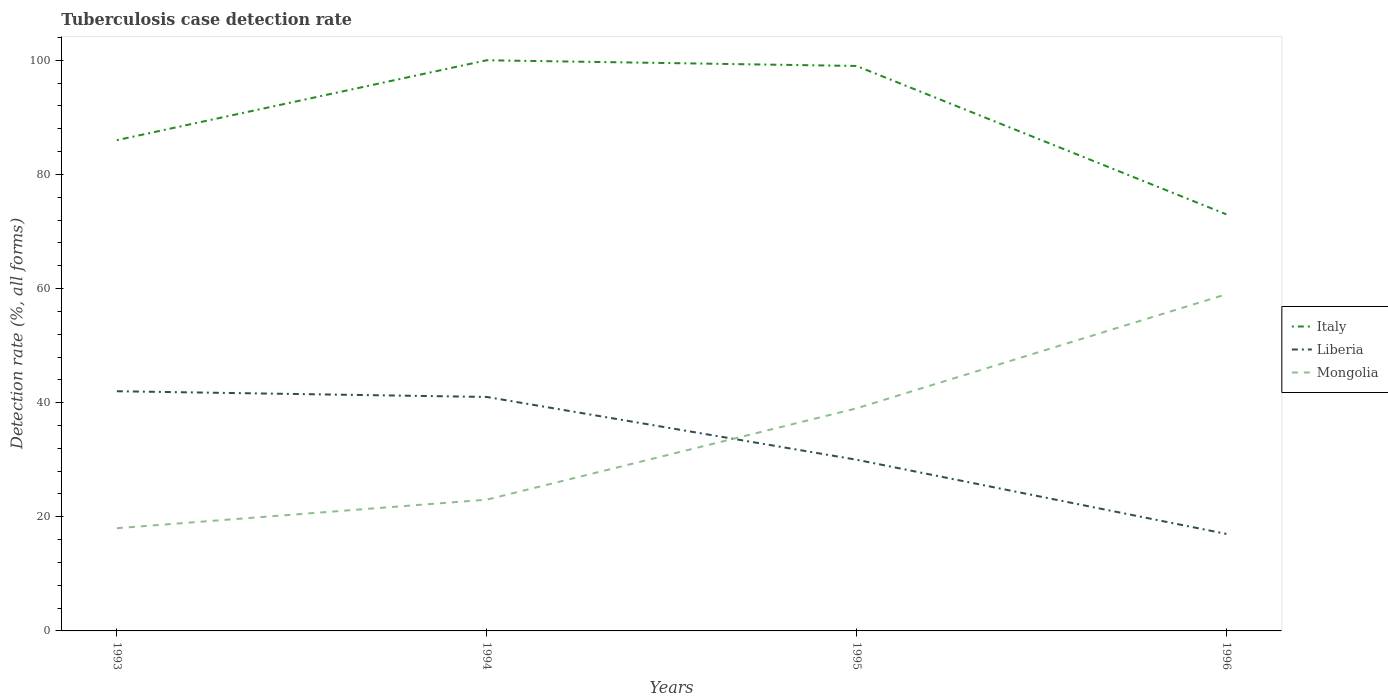How many different coloured lines are there?
Your answer should be very brief. 3. Is the number of lines equal to the number of legend labels?
Your answer should be compact. Yes. In which year was the tuberculosis case detection rate in in Italy maximum?
Offer a terse response. 1996. What is the total tuberculosis case detection rate in in Mongolia in the graph?
Provide a succinct answer. -36. What is the difference between the highest and the second highest tuberculosis case detection rate in in Liberia?
Give a very brief answer. 25. What is the difference between the highest and the lowest tuberculosis case detection rate in in Mongolia?
Ensure brevity in your answer.  2. What is the difference between two consecutive major ticks on the Y-axis?
Keep it short and to the point. 20. Are the values on the major ticks of Y-axis written in scientific E-notation?
Ensure brevity in your answer.  No. Does the graph contain grids?
Keep it short and to the point. No. How many legend labels are there?
Your answer should be very brief. 3. How are the legend labels stacked?
Offer a very short reply. Vertical. What is the title of the graph?
Give a very brief answer. Tuberculosis case detection rate. Does "Yemen, Rep." appear as one of the legend labels in the graph?
Provide a succinct answer. No. What is the label or title of the Y-axis?
Make the answer very short. Detection rate (%, all forms). What is the Detection rate (%, all forms) in Liberia in 1994?
Your response must be concise. 41. What is the Detection rate (%, all forms) of Liberia in 1996?
Make the answer very short. 17. Across all years, what is the maximum Detection rate (%, all forms) of Mongolia?
Offer a very short reply. 59. Across all years, what is the minimum Detection rate (%, all forms) of Liberia?
Your answer should be very brief. 17. Across all years, what is the minimum Detection rate (%, all forms) of Mongolia?
Give a very brief answer. 18. What is the total Detection rate (%, all forms) of Italy in the graph?
Your response must be concise. 358. What is the total Detection rate (%, all forms) in Liberia in the graph?
Keep it short and to the point. 130. What is the total Detection rate (%, all forms) in Mongolia in the graph?
Provide a short and direct response. 139. What is the difference between the Detection rate (%, all forms) of Mongolia in 1993 and that in 1994?
Your response must be concise. -5. What is the difference between the Detection rate (%, all forms) in Italy in 1993 and that in 1995?
Keep it short and to the point. -13. What is the difference between the Detection rate (%, all forms) of Liberia in 1993 and that in 1995?
Your answer should be compact. 12. What is the difference between the Detection rate (%, all forms) of Mongolia in 1993 and that in 1996?
Keep it short and to the point. -41. What is the difference between the Detection rate (%, all forms) of Liberia in 1994 and that in 1996?
Provide a succinct answer. 24. What is the difference between the Detection rate (%, all forms) of Mongolia in 1994 and that in 1996?
Provide a short and direct response. -36. What is the difference between the Detection rate (%, all forms) in Italy in 1993 and the Detection rate (%, all forms) in Liberia in 1994?
Your answer should be compact. 45. What is the difference between the Detection rate (%, all forms) in Italy in 1993 and the Detection rate (%, all forms) in Mongolia in 1994?
Provide a short and direct response. 63. What is the difference between the Detection rate (%, all forms) of Liberia in 1993 and the Detection rate (%, all forms) of Mongolia in 1994?
Offer a very short reply. 19. What is the difference between the Detection rate (%, all forms) of Italy in 1993 and the Detection rate (%, all forms) of Mongolia in 1995?
Your response must be concise. 47. What is the difference between the Detection rate (%, all forms) of Italy in 1993 and the Detection rate (%, all forms) of Mongolia in 1996?
Your answer should be compact. 27. What is the difference between the Detection rate (%, all forms) in Liberia in 1993 and the Detection rate (%, all forms) in Mongolia in 1996?
Provide a succinct answer. -17. What is the difference between the Detection rate (%, all forms) of Italy in 1994 and the Detection rate (%, all forms) of Mongolia in 1996?
Your answer should be very brief. 41. What is the difference between the Detection rate (%, all forms) in Italy in 1995 and the Detection rate (%, all forms) in Liberia in 1996?
Your response must be concise. 82. What is the difference between the Detection rate (%, all forms) in Liberia in 1995 and the Detection rate (%, all forms) in Mongolia in 1996?
Your answer should be compact. -29. What is the average Detection rate (%, all forms) in Italy per year?
Offer a terse response. 89.5. What is the average Detection rate (%, all forms) in Liberia per year?
Keep it short and to the point. 32.5. What is the average Detection rate (%, all forms) in Mongolia per year?
Offer a terse response. 34.75. In the year 1993, what is the difference between the Detection rate (%, all forms) of Italy and Detection rate (%, all forms) of Liberia?
Offer a terse response. 44. In the year 1994, what is the difference between the Detection rate (%, all forms) in Liberia and Detection rate (%, all forms) in Mongolia?
Offer a very short reply. 18. In the year 1995, what is the difference between the Detection rate (%, all forms) in Italy and Detection rate (%, all forms) in Mongolia?
Your answer should be very brief. 60. In the year 1995, what is the difference between the Detection rate (%, all forms) of Liberia and Detection rate (%, all forms) of Mongolia?
Provide a succinct answer. -9. In the year 1996, what is the difference between the Detection rate (%, all forms) of Italy and Detection rate (%, all forms) of Liberia?
Your response must be concise. 56. In the year 1996, what is the difference between the Detection rate (%, all forms) of Liberia and Detection rate (%, all forms) of Mongolia?
Keep it short and to the point. -42. What is the ratio of the Detection rate (%, all forms) in Italy in 1993 to that in 1994?
Give a very brief answer. 0.86. What is the ratio of the Detection rate (%, all forms) in Liberia in 1993 to that in 1994?
Give a very brief answer. 1.02. What is the ratio of the Detection rate (%, all forms) of Mongolia in 1993 to that in 1994?
Ensure brevity in your answer.  0.78. What is the ratio of the Detection rate (%, all forms) of Italy in 1993 to that in 1995?
Make the answer very short. 0.87. What is the ratio of the Detection rate (%, all forms) in Liberia in 1993 to that in 1995?
Give a very brief answer. 1.4. What is the ratio of the Detection rate (%, all forms) of Mongolia in 1993 to that in 1995?
Offer a very short reply. 0.46. What is the ratio of the Detection rate (%, all forms) in Italy in 1993 to that in 1996?
Provide a short and direct response. 1.18. What is the ratio of the Detection rate (%, all forms) in Liberia in 1993 to that in 1996?
Provide a succinct answer. 2.47. What is the ratio of the Detection rate (%, all forms) in Mongolia in 1993 to that in 1996?
Your response must be concise. 0.31. What is the ratio of the Detection rate (%, all forms) of Liberia in 1994 to that in 1995?
Give a very brief answer. 1.37. What is the ratio of the Detection rate (%, all forms) of Mongolia in 1994 to that in 1995?
Ensure brevity in your answer.  0.59. What is the ratio of the Detection rate (%, all forms) in Italy in 1994 to that in 1996?
Provide a short and direct response. 1.37. What is the ratio of the Detection rate (%, all forms) in Liberia in 1994 to that in 1996?
Provide a succinct answer. 2.41. What is the ratio of the Detection rate (%, all forms) of Mongolia in 1994 to that in 1996?
Provide a succinct answer. 0.39. What is the ratio of the Detection rate (%, all forms) in Italy in 1995 to that in 1996?
Your response must be concise. 1.36. What is the ratio of the Detection rate (%, all forms) of Liberia in 1995 to that in 1996?
Your answer should be compact. 1.76. What is the ratio of the Detection rate (%, all forms) of Mongolia in 1995 to that in 1996?
Make the answer very short. 0.66. What is the difference between the highest and the second highest Detection rate (%, all forms) in Liberia?
Offer a terse response. 1. What is the difference between the highest and the second highest Detection rate (%, all forms) in Mongolia?
Offer a terse response. 20. What is the difference between the highest and the lowest Detection rate (%, all forms) in Italy?
Your answer should be very brief. 27. 